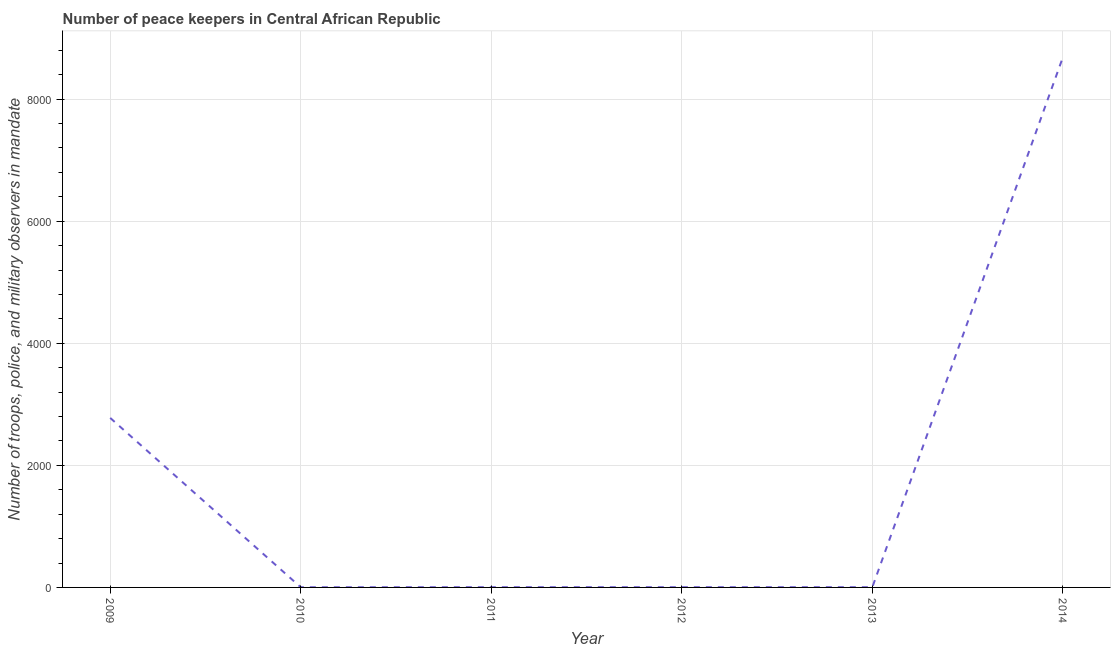What is the number of peace keepers in 2013?
Provide a succinct answer. 4. Across all years, what is the maximum number of peace keepers?
Make the answer very short. 8685. Across all years, what is the minimum number of peace keepers?
Your answer should be very brief. 3. In which year was the number of peace keepers maximum?
Give a very brief answer. 2014. In which year was the number of peace keepers minimum?
Provide a succinct answer. 2010. What is the sum of the number of peace keepers?
Your answer should be very brief. 1.15e+04. What is the difference between the number of peace keepers in 2009 and 2014?
Your answer should be compact. -5908. What is the average number of peace keepers per year?
Offer a terse response. 1912.83. What is the median number of peace keepers?
Ensure brevity in your answer.  4. In how many years, is the number of peace keepers greater than 3200 ?
Provide a succinct answer. 1. What is the ratio of the number of peace keepers in 2013 to that in 2014?
Give a very brief answer. 0. Is the number of peace keepers in 2009 less than that in 2013?
Keep it short and to the point. No. What is the difference between the highest and the second highest number of peace keepers?
Provide a succinct answer. 5908. What is the difference between the highest and the lowest number of peace keepers?
Offer a very short reply. 8682. How many years are there in the graph?
Your answer should be very brief. 6. What is the difference between two consecutive major ticks on the Y-axis?
Your answer should be very brief. 2000. Does the graph contain any zero values?
Offer a terse response. No. Does the graph contain grids?
Your answer should be compact. Yes. What is the title of the graph?
Offer a very short reply. Number of peace keepers in Central African Republic. What is the label or title of the Y-axis?
Your response must be concise. Number of troops, police, and military observers in mandate. What is the Number of troops, police, and military observers in mandate in 2009?
Your response must be concise. 2777. What is the Number of troops, police, and military observers in mandate in 2011?
Keep it short and to the point. 4. What is the Number of troops, police, and military observers in mandate of 2012?
Offer a terse response. 4. What is the Number of troops, police, and military observers in mandate of 2013?
Your response must be concise. 4. What is the Number of troops, police, and military observers in mandate of 2014?
Ensure brevity in your answer.  8685. What is the difference between the Number of troops, police, and military observers in mandate in 2009 and 2010?
Give a very brief answer. 2774. What is the difference between the Number of troops, police, and military observers in mandate in 2009 and 2011?
Provide a succinct answer. 2773. What is the difference between the Number of troops, police, and military observers in mandate in 2009 and 2012?
Ensure brevity in your answer.  2773. What is the difference between the Number of troops, police, and military observers in mandate in 2009 and 2013?
Ensure brevity in your answer.  2773. What is the difference between the Number of troops, police, and military observers in mandate in 2009 and 2014?
Offer a terse response. -5908. What is the difference between the Number of troops, police, and military observers in mandate in 2010 and 2011?
Your answer should be very brief. -1. What is the difference between the Number of troops, police, and military observers in mandate in 2010 and 2014?
Your answer should be very brief. -8682. What is the difference between the Number of troops, police, and military observers in mandate in 2011 and 2012?
Your answer should be very brief. 0. What is the difference between the Number of troops, police, and military observers in mandate in 2011 and 2013?
Your response must be concise. 0. What is the difference between the Number of troops, police, and military observers in mandate in 2011 and 2014?
Your response must be concise. -8681. What is the difference between the Number of troops, police, and military observers in mandate in 2012 and 2014?
Ensure brevity in your answer.  -8681. What is the difference between the Number of troops, police, and military observers in mandate in 2013 and 2014?
Provide a short and direct response. -8681. What is the ratio of the Number of troops, police, and military observers in mandate in 2009 to that in 2010?
Your answer should be compact. 925.67. What is the ratio of the Number of troops, police, and military observers in mandate in 2009 to that in 2011?
Make the answer very short. 694.25. What is the ratio of the Number of troops, police, and military observers in mandate in 2009 to that in 2012?
Offer a terse response. 694.25. What is the ratio of the Number of troops, police, and military observers in mandate in 2009 to that in 2013?
Provide a succinct answer. 694.25. What is the ratio of the Number of troops, police, and military observers in mandate in 2009 to that in 2014?
Give a very brief answer. 0.32. What is the ratio of the Number of troops, police, and military observers in mandate in 2010 to that in 2011?
Your answer should be compact. 0.75. What is the ratio of the Number of troops, police, and military observers in mandate in 2010 to that in 2012?
Your response must be concise. 0.75. What is the ratio of the Number of troops, police, and military observers in mandate in 2010 to that in 2013?
Give a very brief answer. 0.75. What is the ratio of the Number of troops, police, and military observers in mandate in 2011 to that in 2013?
Provide a succinct answer. 1. What is the ratio of the Number of troops, police, and military observers in mandate in 2011 to that in 2014?
Provide a succinct answer. 0. What is the ratio of the Number of troops, police, and military observers in mandate in 2013 to that in 2014?
Your answer should be compact. 0. 